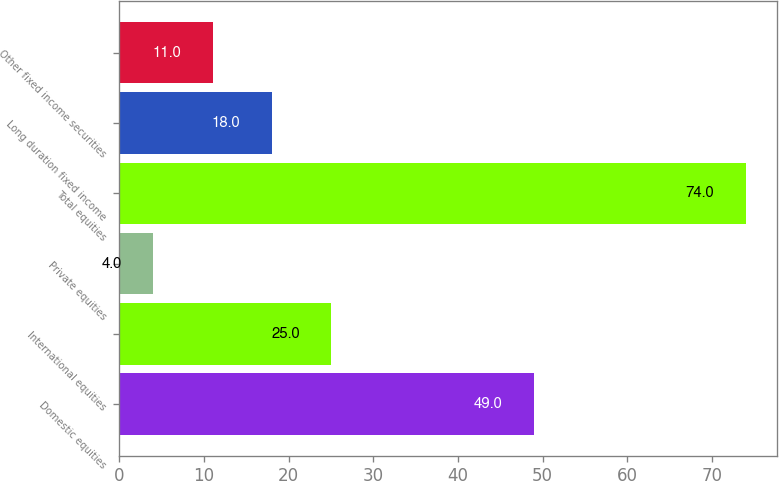<chart> <loc_0><loc_0><loc_500><loc_500><bar_chart><fcel>Domestic equities<fcel>International equities<fcel>Private equities<fcel>Total equities<fcel>Long duration fixed income<fcel>Other fixed income securities<nl><fcel>49<fcel>25<fcel>4<fcel>74<fcel>18<fcel>11<nl></chart> 